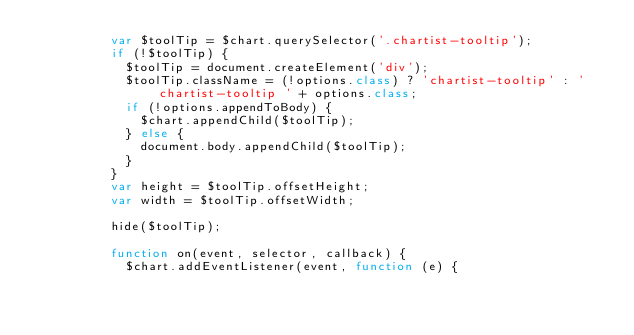<code> <loc_0><loc_0><loc_500><loc_500><_JavaScript_>          var $toolTip = $chart.querySelector('.chartist-tooltip');
          if (!$toolTip) {
            $toolTip = document.createElement('div');
            $toolTip.className = (!options.class) ? 'chartist-tooltip' : 'chartist-tooltip ' + options.class;
            if (!options.appendToBody) {
              $chart.appendChild($toolTip);
            } else {
              document.body.appendChild($toolTip);
            }
          }
          var height = $toolTip.offsetHeight;
          var width = $toolTip.offsetWidth;
  
          hide($toolTip);
  
          function on(event, selector, callback) {
            $chart.addEventListener(event, function (e) {</code> 